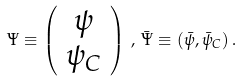<formula> <loc_0><loc_0><loc_500><loc_500>\Psi \equiv \left ( \begin{array} { c } \psi \\ \psi _ { C } \end{array} \right ) \, , \, \bar { \Psi } \equiv ( \bar { \psi } , \bar { \psi } _ { C } ) \, .</formula> 